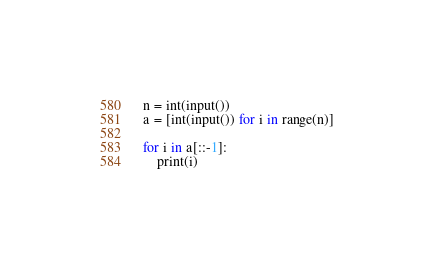<code> <loc_0><loc_0><loc_500><loc_500><_Python_>n = int(input())
a = [int(input()) for i in range(n)]

for i in a[::-1]:
    print(i)
</code> 